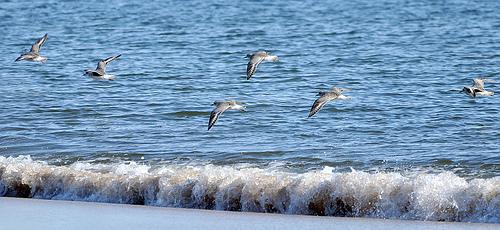Question: how many birds are flying?
Choices:
A. 7.
B. 5.
C. 8.
D. 6.
Answer with the letter. Answer: D Question: what is the color of the water?
Choices:
A. Blue.
B. Pink.
C. Orange.
D. Yellow.
Answer with the letter. Answer: A Question: what are the birds doing?
Choices:
A. Flying.
B. Walking.
C. Running.
D. Swimming.
Answer with the letter. Answer: A Question: what is the water having?
Choices:
A. Rocks.
B. Waves.
C. Garbage.
D. Fish.
Answer with the letter. Answer: B Question: where was the pic taken?
Choices:
A. In the ocean.
B. Land.
C. Park.
D. Zoo.
Answer with the letter. Answer: A Question: why are there waves?
Choices:
A. The water is angry.
B. The water is moving fast.
C. The water is in a hurry.
D. The water is afraid.
Answer with the letter. Answer: B 